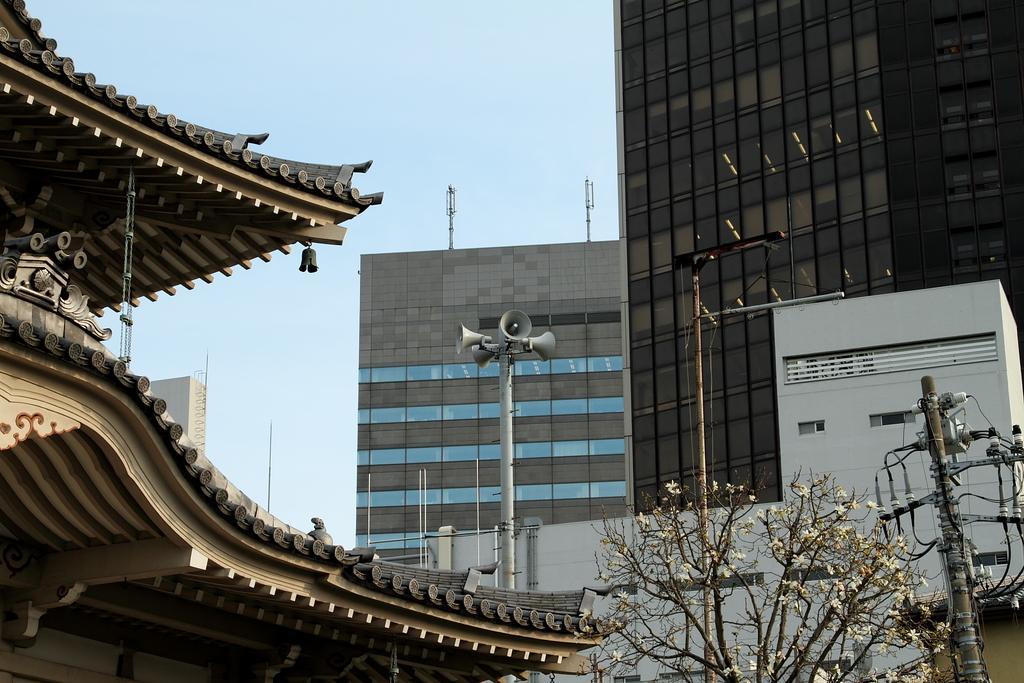Could you give a brief overview of what you see in this image? In this image there are buildings, on top of the buildings there are antennas and there are trees, electric poles and a pole with speakers on it. 